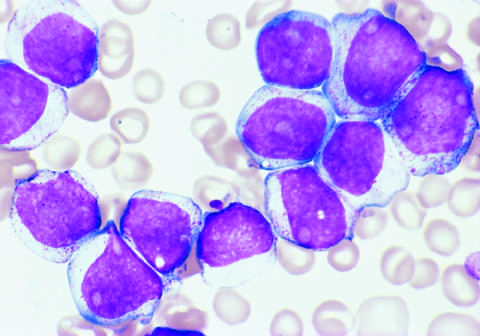what results for the aml are shown in the figure?
Answer the question using a single word or phrase. Flow cytometry 